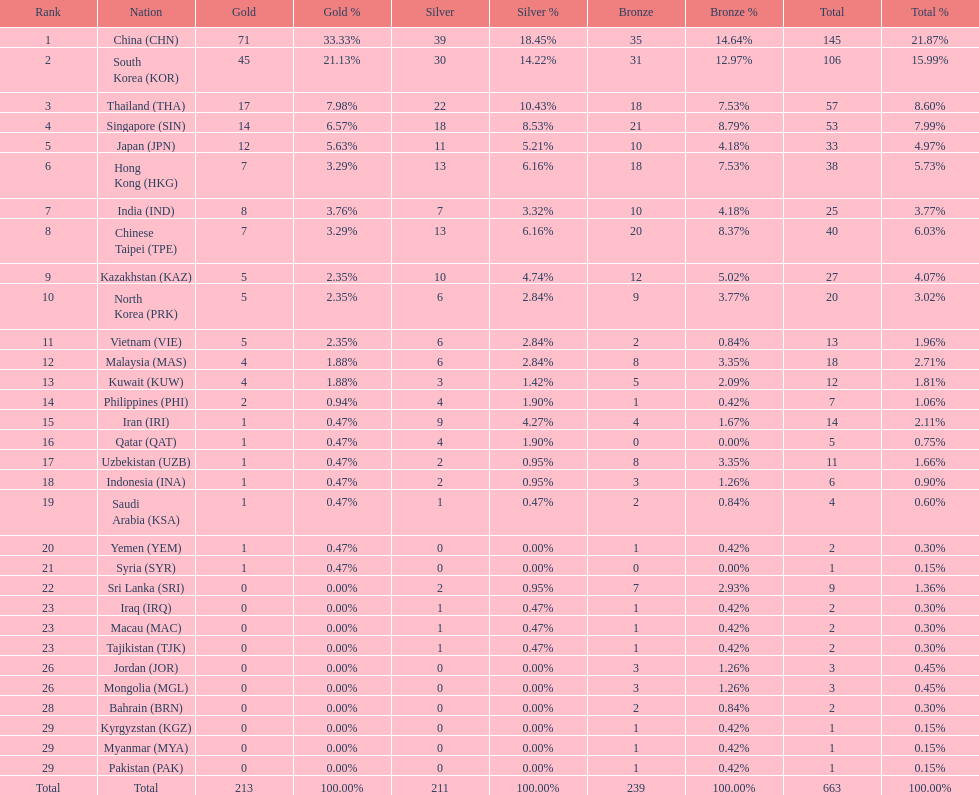What were the number of medals iran earned? 14. 